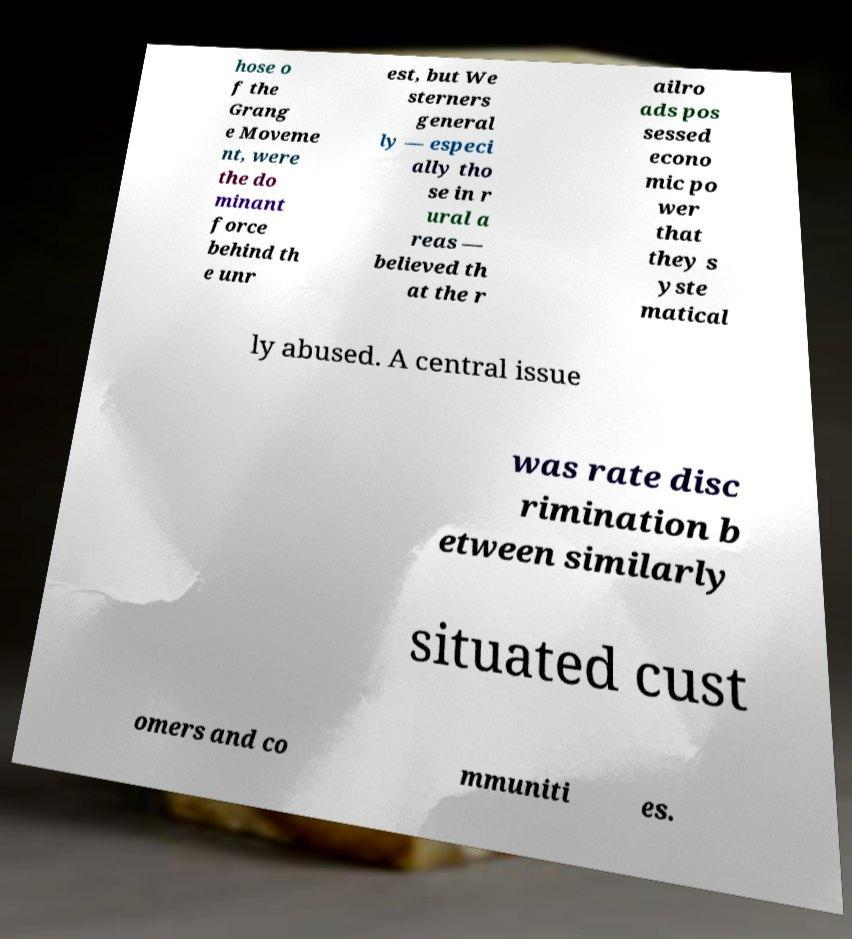There's text embedded in this image that I need extracted. Can you transcribe it verbatim? hose o f the Grang e Moveme nt, were the do minant force behind th e unr est, but We sterners general ly — especi ally tho se in r ural a reas — believed th at the r ailro ads pos sessed econo mic po wer that they s yste matical ly abused. A central issue was rate disc rimination b etween similarly situated cust omers and co mmuniti es. 